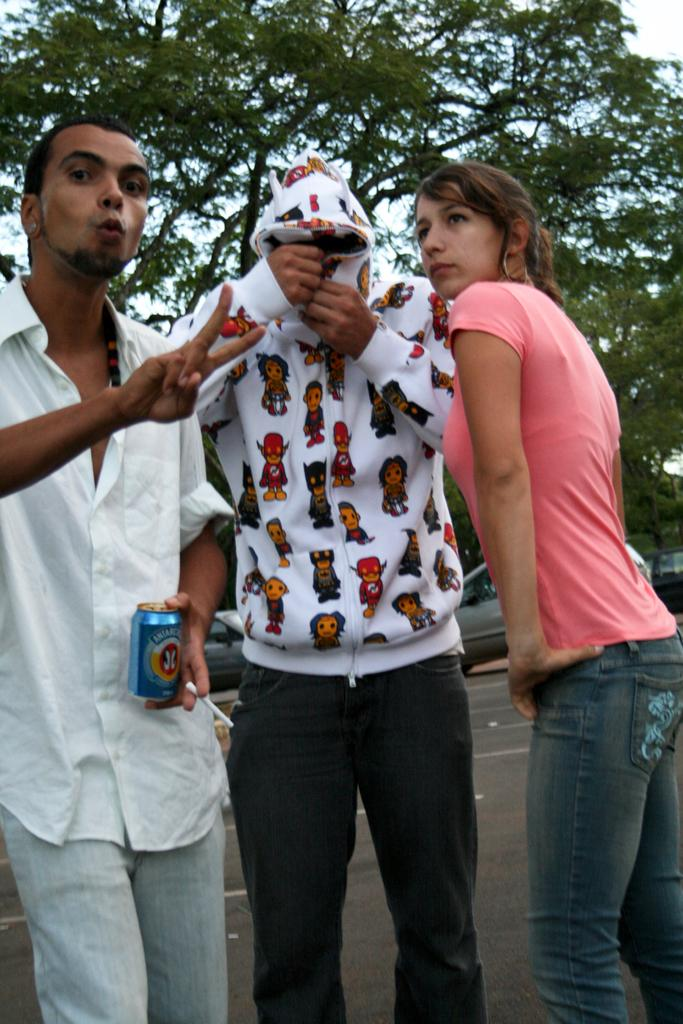How many people are present in the image? There are three people standing in the image. What is the man on the left holding? The man on the left is holding a tin. What can be seen in the background of the image? There are cars, trees, and the sky visible in the background of the image. What type of hill can be seen in the background of the image? There is no hill present in the background of the image; it features cars, trees, and the sky. What scale is being used to measure the size of the cars in the image? There is no scale present in the image, and the size of the cars is not being measured. 